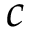<formula> <loc_0><loc_0><loc_500><loc_500>c</formula> 